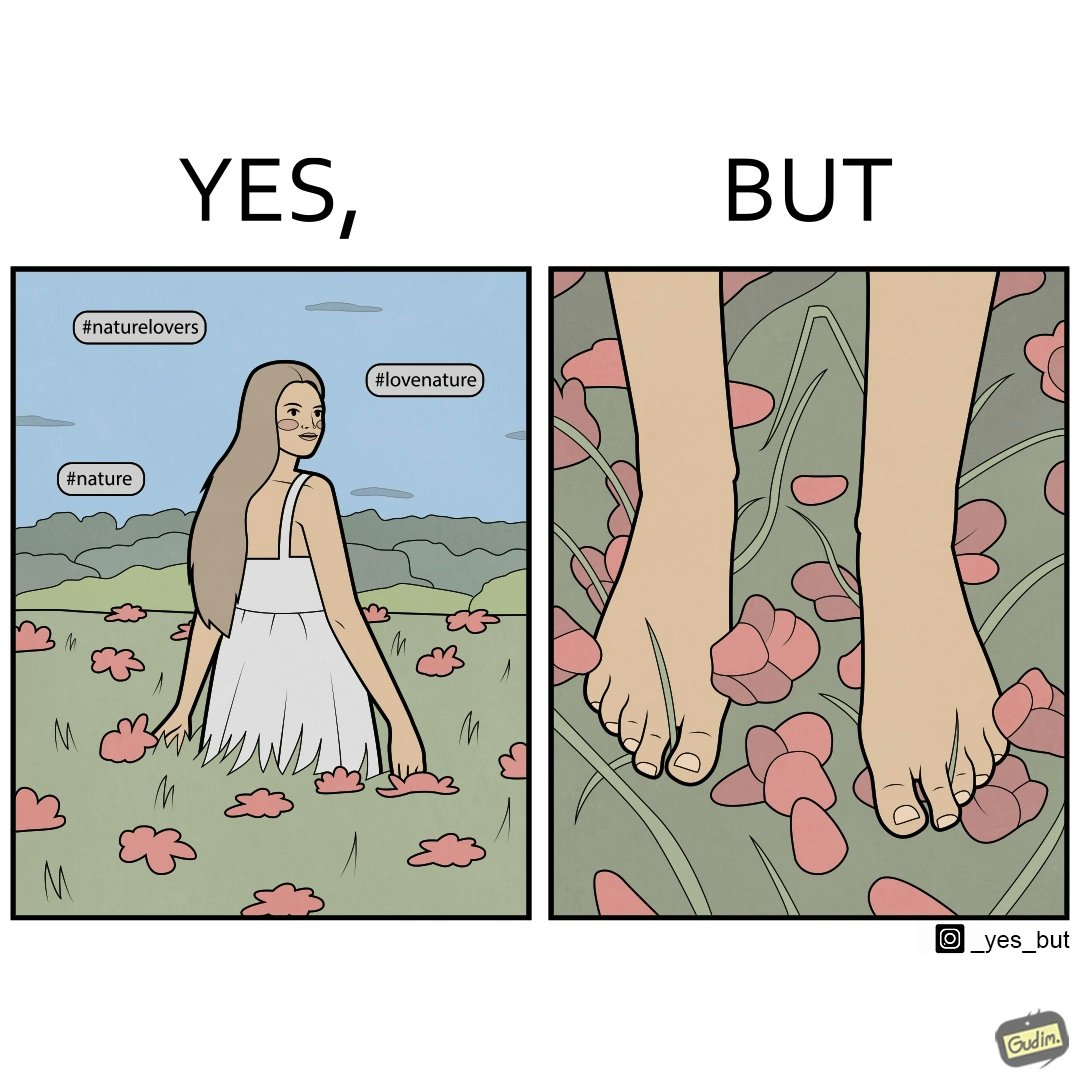Provide a description of this image. The image is ironical, as the social ,edia post shows the appreciation of nature, while an image of the feet on the ground stepping on the flower petals shows an unintentional disrespect of nature. 